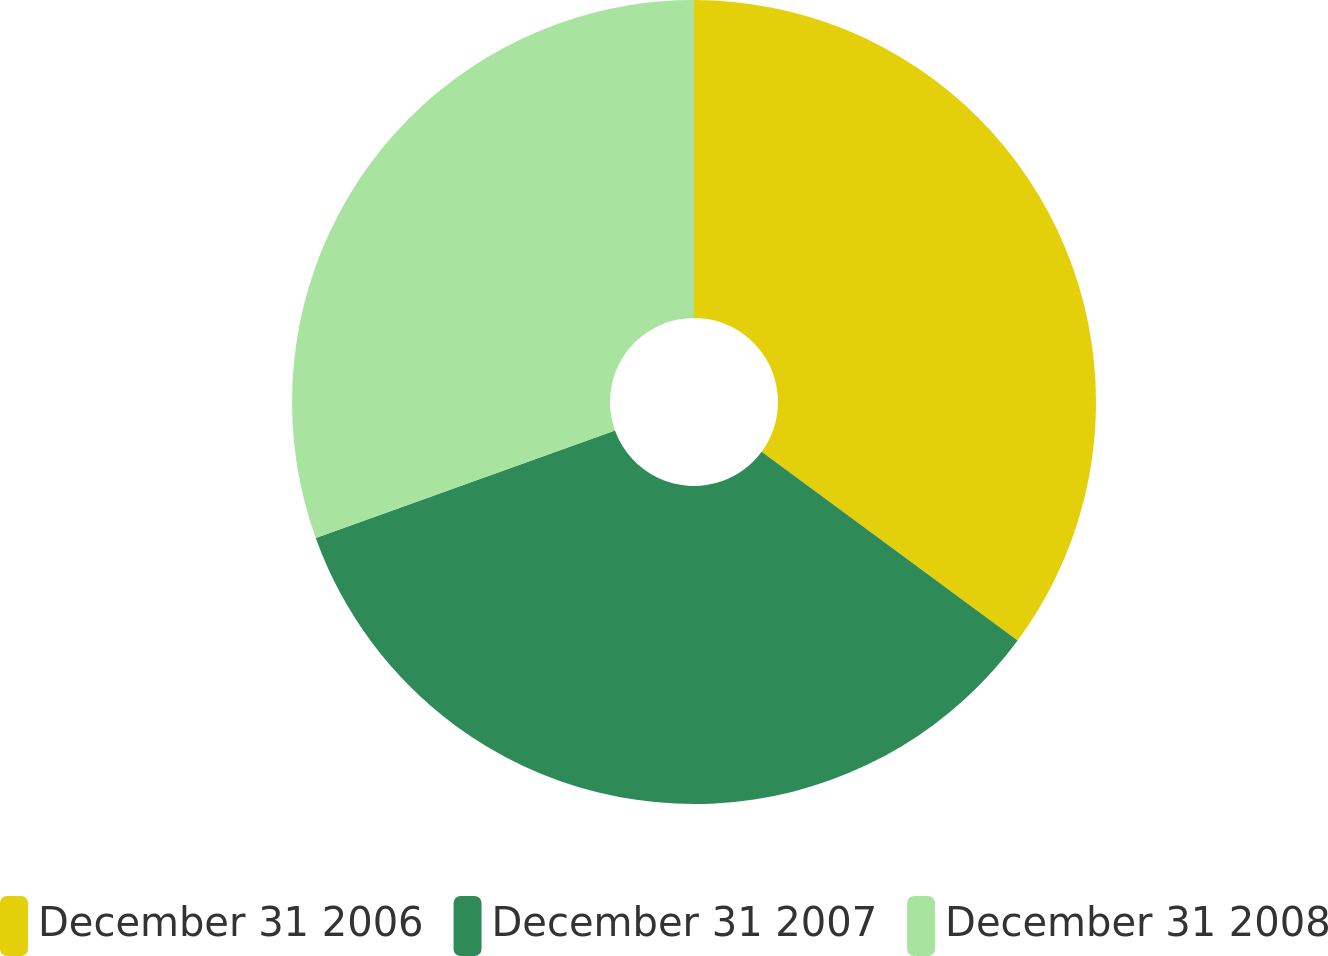<chart> <loc_0><loc_0><loc_500><loc_500><pie_chart><fcel>December 31 2006<fcel>December 31 2007<fcel>December 31 2008<nl><fcel>35.11%<fcel>34.4%<fcel>30.5%<nl></chart> 